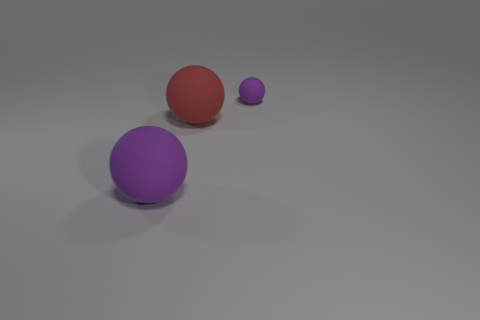Subtract all purple spheres. How many spheres are left? 1 Subtract all green blocks. How many purple balls are left? 2 Add 2 tiny gray things. How many objects exist? 5 Subtract all gray balls. Subtract all cyan cylinders. How many balls are left? 3 Subtract all yellow rubber cylinders. Subtract all big purple matte balls. How many objects are left? 2 Add 1 big rubber objects. How many big rubber objects are left? 3 Add 3 large red things. How many large red things exist? 4 Subtract 0 green cylinders. How many objects are left? 3 